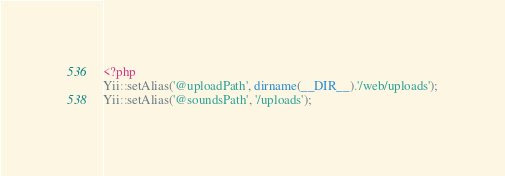<code> <loc_0><loc_0><loc_500><loc_500><_PHP_><?php
Yii::setAlias('@uploadPath', dirname(__DIR__).'/web/uploads');
Yii::setAlias('@soundsPath', '/uploads');</code> 